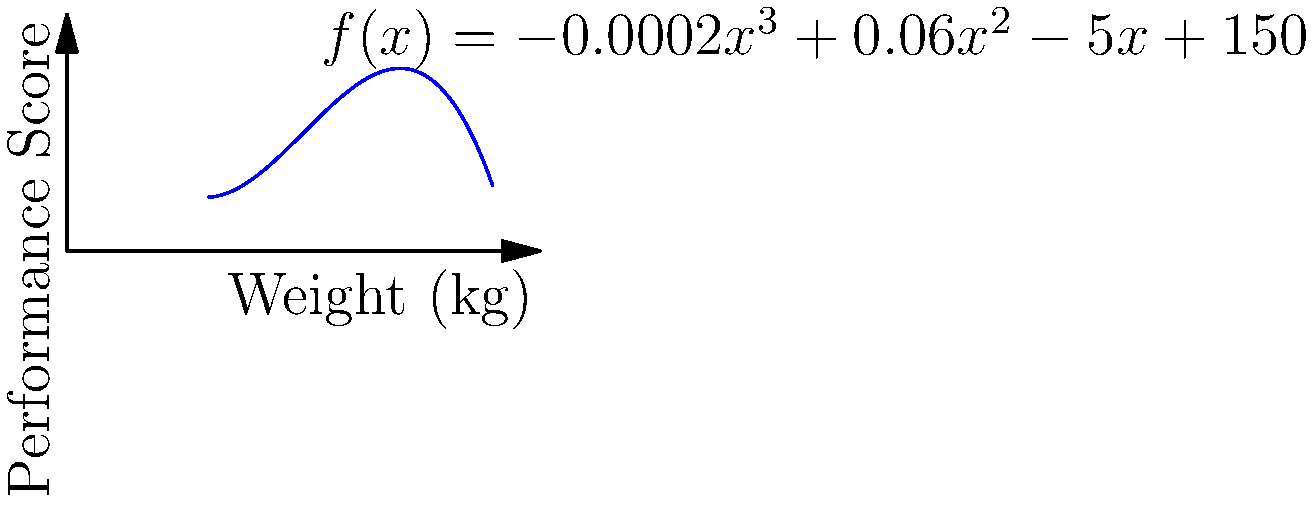In Sri Lankan professional wrestling, a wrestler's performance score is modeled by the polynomial function $f(x) = -0.0002x^3 + 0.06x^2 - 5x + 150$, where $x$ is the wrestler's weight in kilograms. At what weight does a wrestler achieve the maximum performance score? To find the weight at which the wrestler achieves the maximum performance score, we need to follow these steps:

1) The maximum point of a function occurs where its derivative equals zero. So, we need to find $f'(x)$ and set it to zero.

2) $f'(x) = -0.0006x^2 + 0.12x - 5$

3) Set $f'(x) = 0$:
   $-0.0006x^2 + 0.12x - 5 = 0$

4) This is a quadratic equation. We can solve it using the quadratic formula:
   $x = \frac{-b \pm \sqrt{b^2 - 4ac}}{2a}$

   Where $a = -0.0006$, $b = 0.12$, and $c = -5$

5) Plugging these values into the quadratic formula:
   $x = \frac{-0.12 \pm \sqrt{0.12^2 - 4(-0.0006)(-5)}}{2(-0.0006)}$

6) Simplifying:
   $x = \frac{-0.12 \pm \sqrt{0.0144 + 0.012}}{-0.0012}$
   $x = \frac{-0.12 \pm \sqrt{0.0264}}{-0.0012}$
   $x = \frac{-0.12 \pm 0.1625}{-0.0012}$

7) This gives us two solutions:
   $x_1 = \frac{-0.12 + 0.1625}{-0.0012} \approx 35.42$
   $x_2 = \frac{-0.12 - 0.1625}{-0.0012} \approx 235.42$

8) Since the weight of a wrestler cannot be 235.42 kg in typical scenarios, the realistic solution is 35.42 kg.

Therefore, a wrestler achieves the maximum performance score at approximately 35.42 kg.
Answer: 35.42 kg 